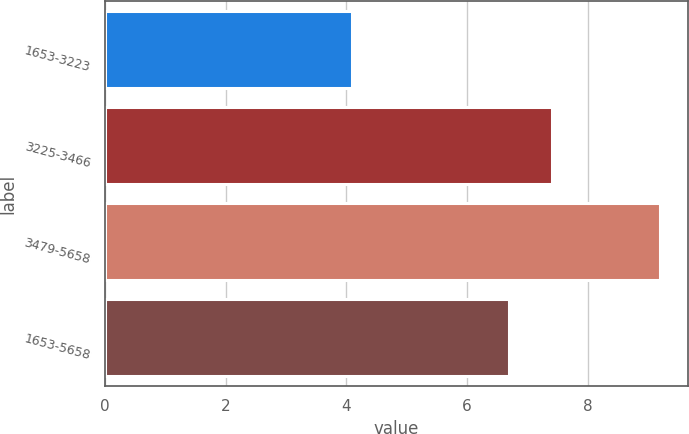Convert chart to OTSL. <chart><loc_0><loc_0><loc_500><loc_500><bar_chart><fcel>1653-3223<fcel>3225-3466<fcel>3479-5658<fcel>1653-5658<nl><fcel>4.1<fcel>7.4<fcel>9.2<fcel>6.7<nl></chart> 